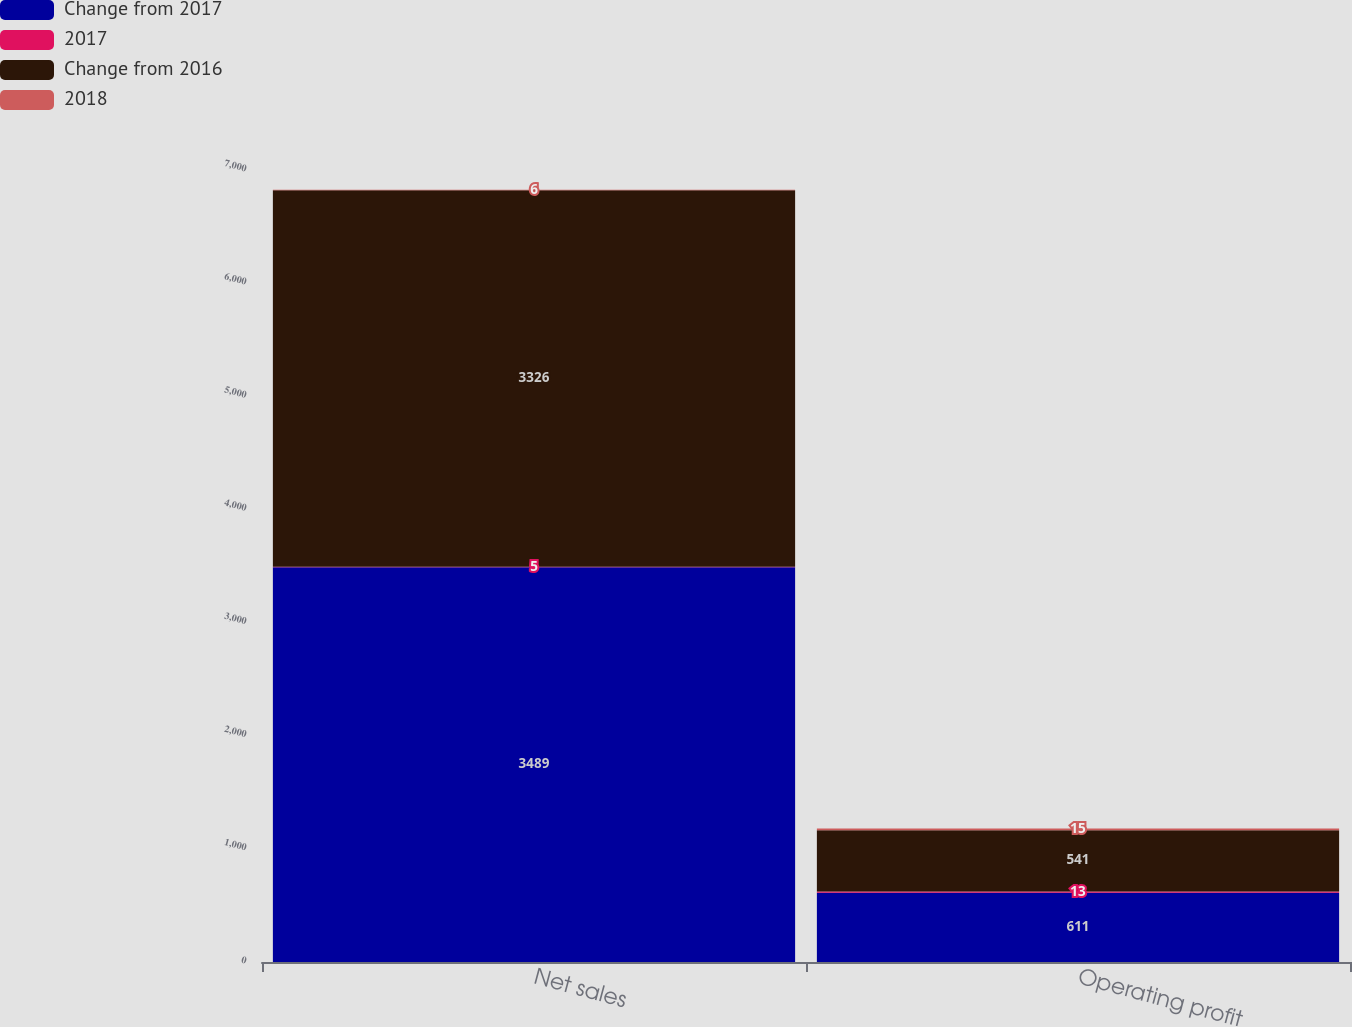<chart> <loc_0><loc_0><loc_500><loc_500><stacked_bar_chart><ecel><fcel>Net sales<fcel>Operating profit<nl><fcel>Change from 2017<fcel>3489<fcel>611<nl><fcel>2017<fcel>5<fcel>13<nl><fcel>Change from 2016<fcel>3326<fcel>541<nl><fcel>2018<fcel>6<fcel>15<nl></chart> 